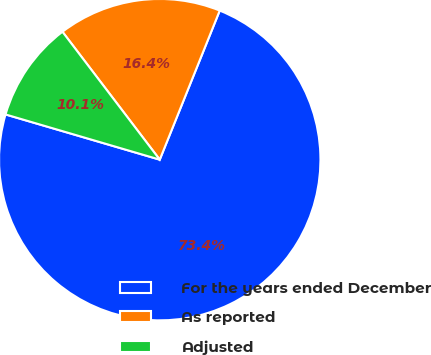<chart> <loc_0><loc_0><loc_500><loc_500><pie_chart><fcel>For the years ended December<fcel>As reported<fcel>Adjusted<nl><fcel>73.45%<fcel>16.44%<fcel>10.11%<nl></chart> 